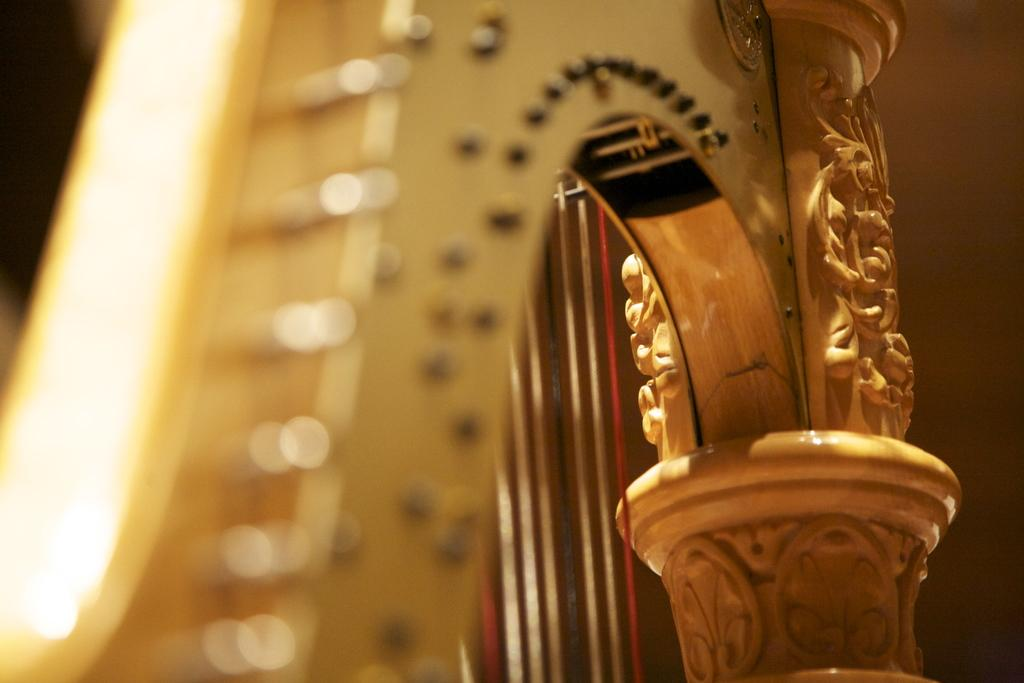What type of musical instrument is in the image? There is a wooden musical instrument in the image. What feature does the musical instrument have? The musical instrument has strings. Is there any decoration on the wooden surface of the instrument? Yes, there is artwork on the wooden surface of the instrument. Is there a servant holding a rake in the image? No, there is no servant or rake present in the image. 